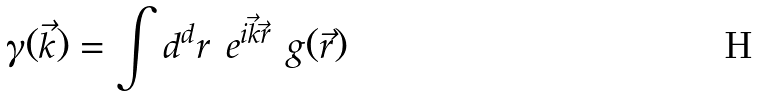Convert formula to latex. <formula><loc_0><loc_0><loc_500><loc_500>\gamma ( \vec { k } ) = \int { d } ^ { d } r \ e ^ { i \vec { k } \vec { r } } \ g ( \vec { r } )</formula> 